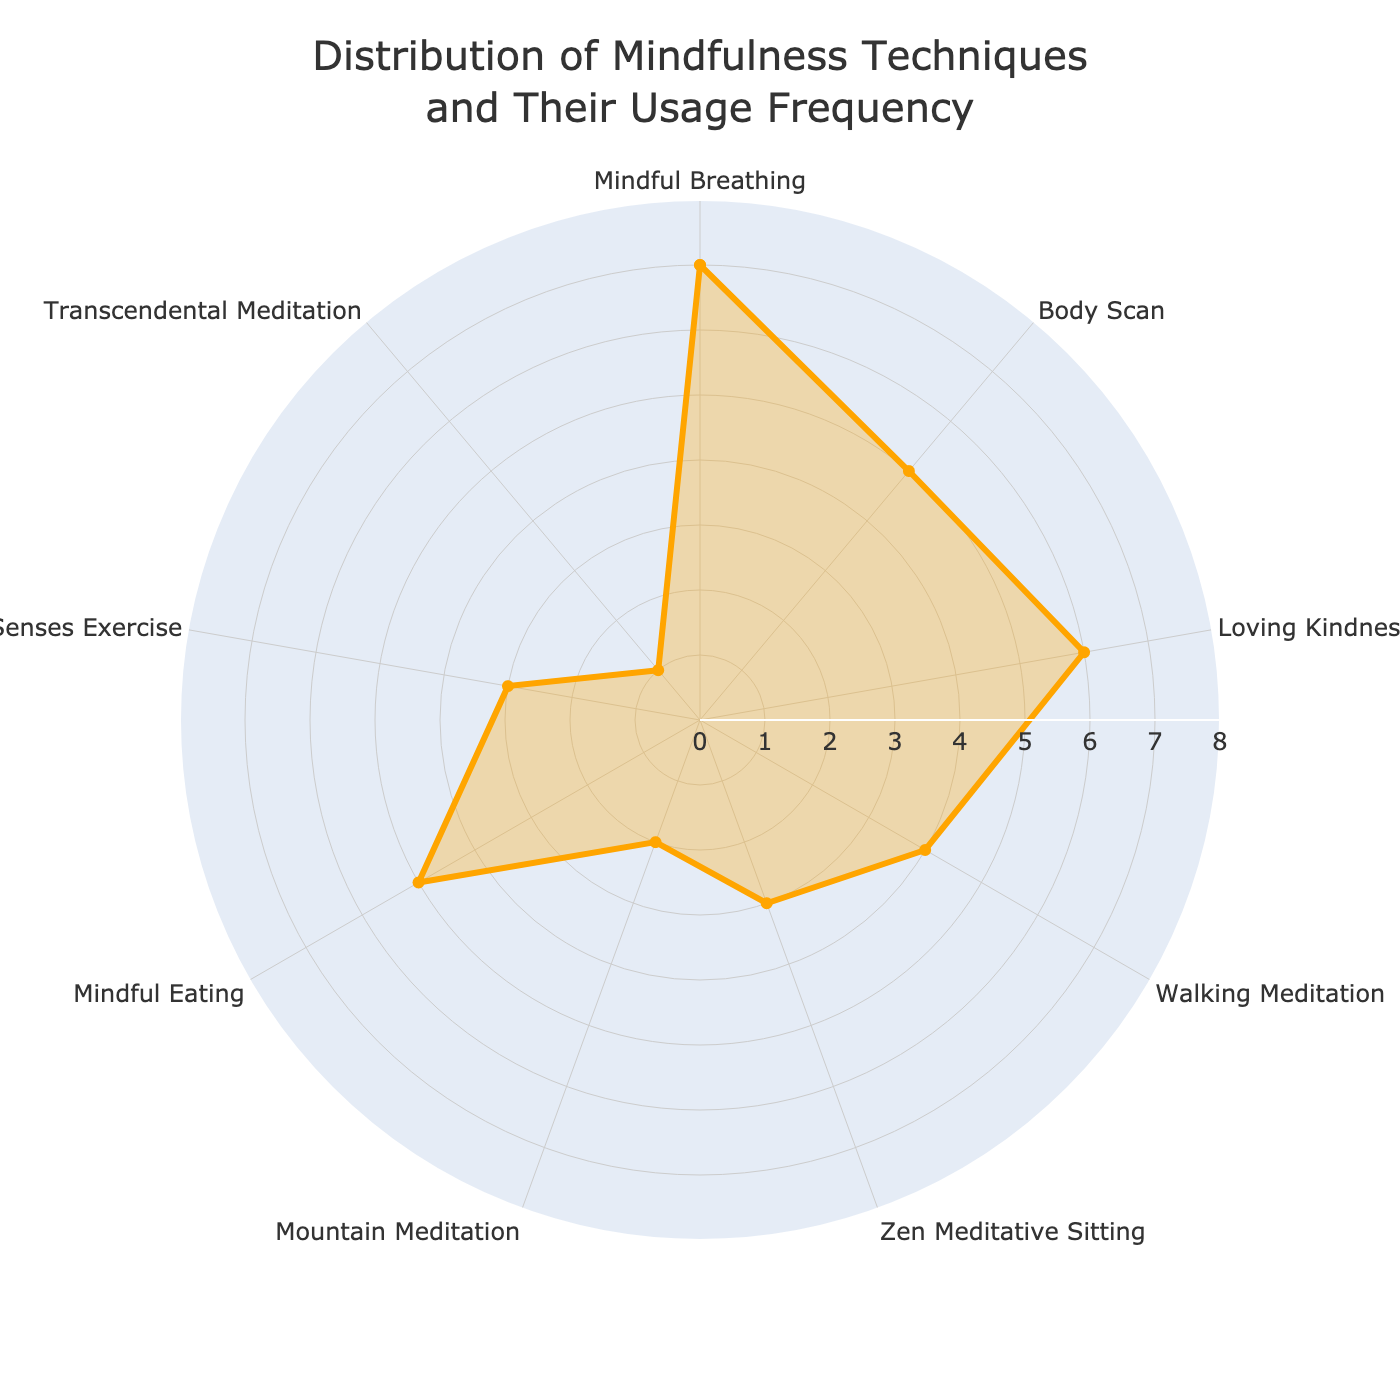What is the title of the chart? The title of the chart is displayed at the top center of the figure.
Answer: Distribution of Mindfulness Techniques and Their Usage Frequency Which mindfulness technique is practiced the most weekly? By looking at the chart, the technique positioned at the top of the frequency range would indicate the highest value. In this case, it's Mindful Breathing.
Answer: Mindful Breathing How many techniques are practiced less than 4 times a week? Observing the frequency values, count those techniques with values less than 4. These are Zen Meditative Sitting, Five Senses Exercise, Mountain Meditation, and Transcendental Meditation, totaling 4 techniques.
Answer: 4 Which techniques share the same weekly frequency of practice at 5 times a week? Locate the frequency value of 5 and check which techniques are plotted at this level. Both Body Scan and Mindful Eating are practiced 5 times a week.
Answer: Body Scan, Mindful Eating What is the difference in weekly frequency between the most and least practiced techniques? Find the highest frequency (7 for Mindful Breathing) and the lowest frequency (1 for Transcendental Meditation) and subtract the latter from the former: 7 - 1 = 6.
Answer: 6 Which technique showed up positioned exactly between Mindful Breathing and Walking Meditation? When you look clockwise on the radar chart, the technique between them is Loving Kindness Meditation.
Answer: Loving Kindness Meditation How many angles/tick markers are present around the radar chart? Observe the chart’s circumference for the angular tick markers corresponding to the number of techniques listed, which totals 9.
Answer: 9 Is there any technique practiced exactly 3 times a week? By observing the frequency values, Zen Meditative Sitting and Five Senses Exercise are each practiced 3 times a week.
Answer: Zen Meditative Sitting, Five Senses Exercise Which technique has the closest weekly practice frequency to Walking Meditation? Walking Meditation is practiced 4 times a week. The closest frequency in the radar chart is Zen Meditative Sitting and Five Senses Exercise, practiced 3 times a week (1 less).
Answer: Zen Meditative Sitting, Five Senses Exercise 